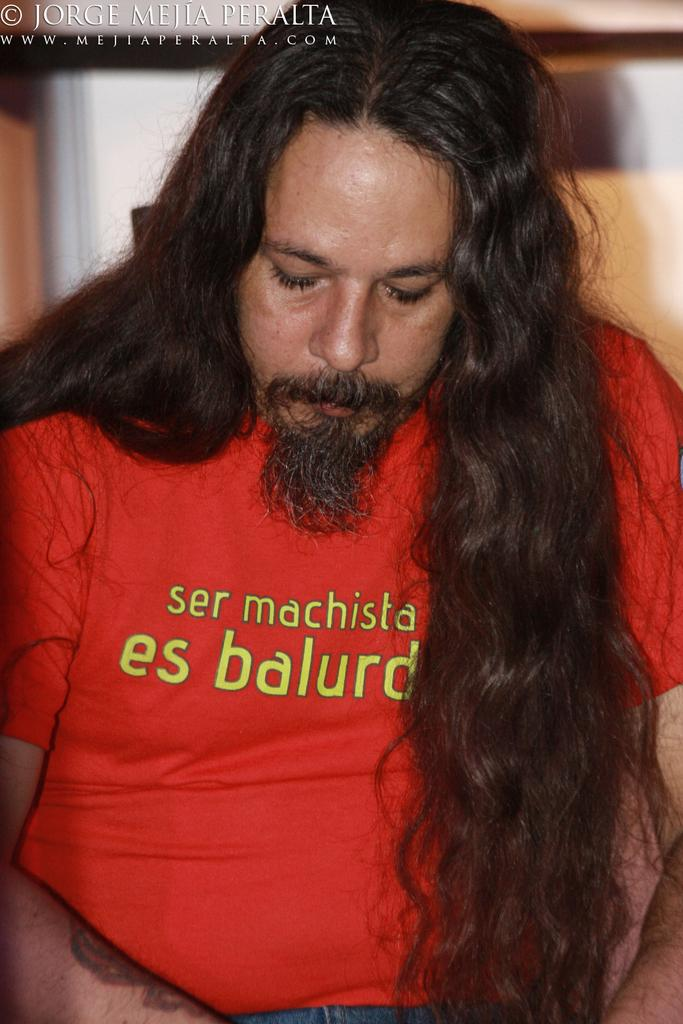Who is present in the image? There is a person in the image. What is the person wearing? The person is wearing a red t-shirt. Can you describe the person's hair? The person has long hair. What can be seen in the background of the image? There is text visible in the background of the image. What type of wound can be seen on the person's arm in the image? There is no wound visible on the person's arm in the image. What discovery is the person making in the image? The image does not depict a discovery being made by the person. 